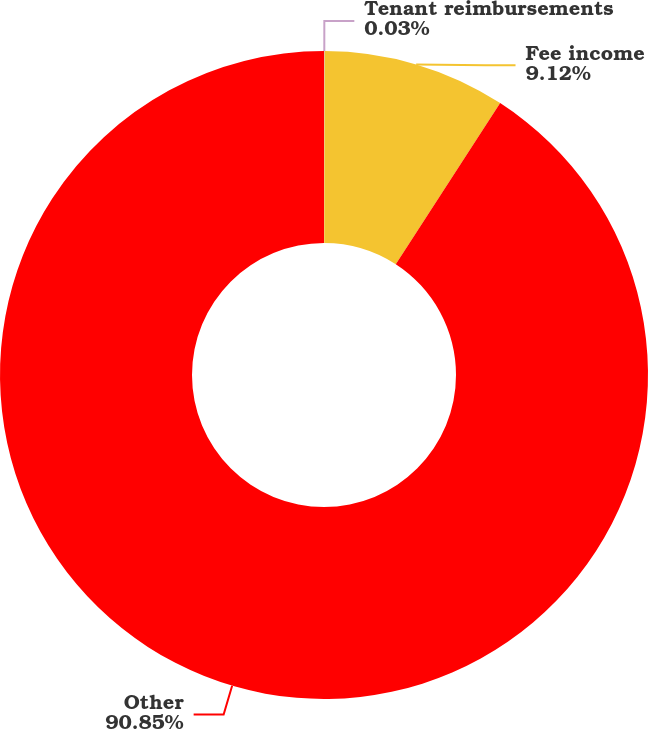<chart> <loc_0><loc_0><loc_500><loc_500><pie_chart><fcel>Tenant reimbursements<fcel>Fee income<fcel>Other<nl><fcel>0.03%<fcel>9.12%<fcel>90.85%<nl></chart> 